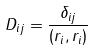Convert formula to latex. <formula><loc_0><loc_0><loc_500><loc_500>D _ { i j } = \frac { \delta _ { i j } } { ( r _ { i } , r _ { i } ) }</formula> 